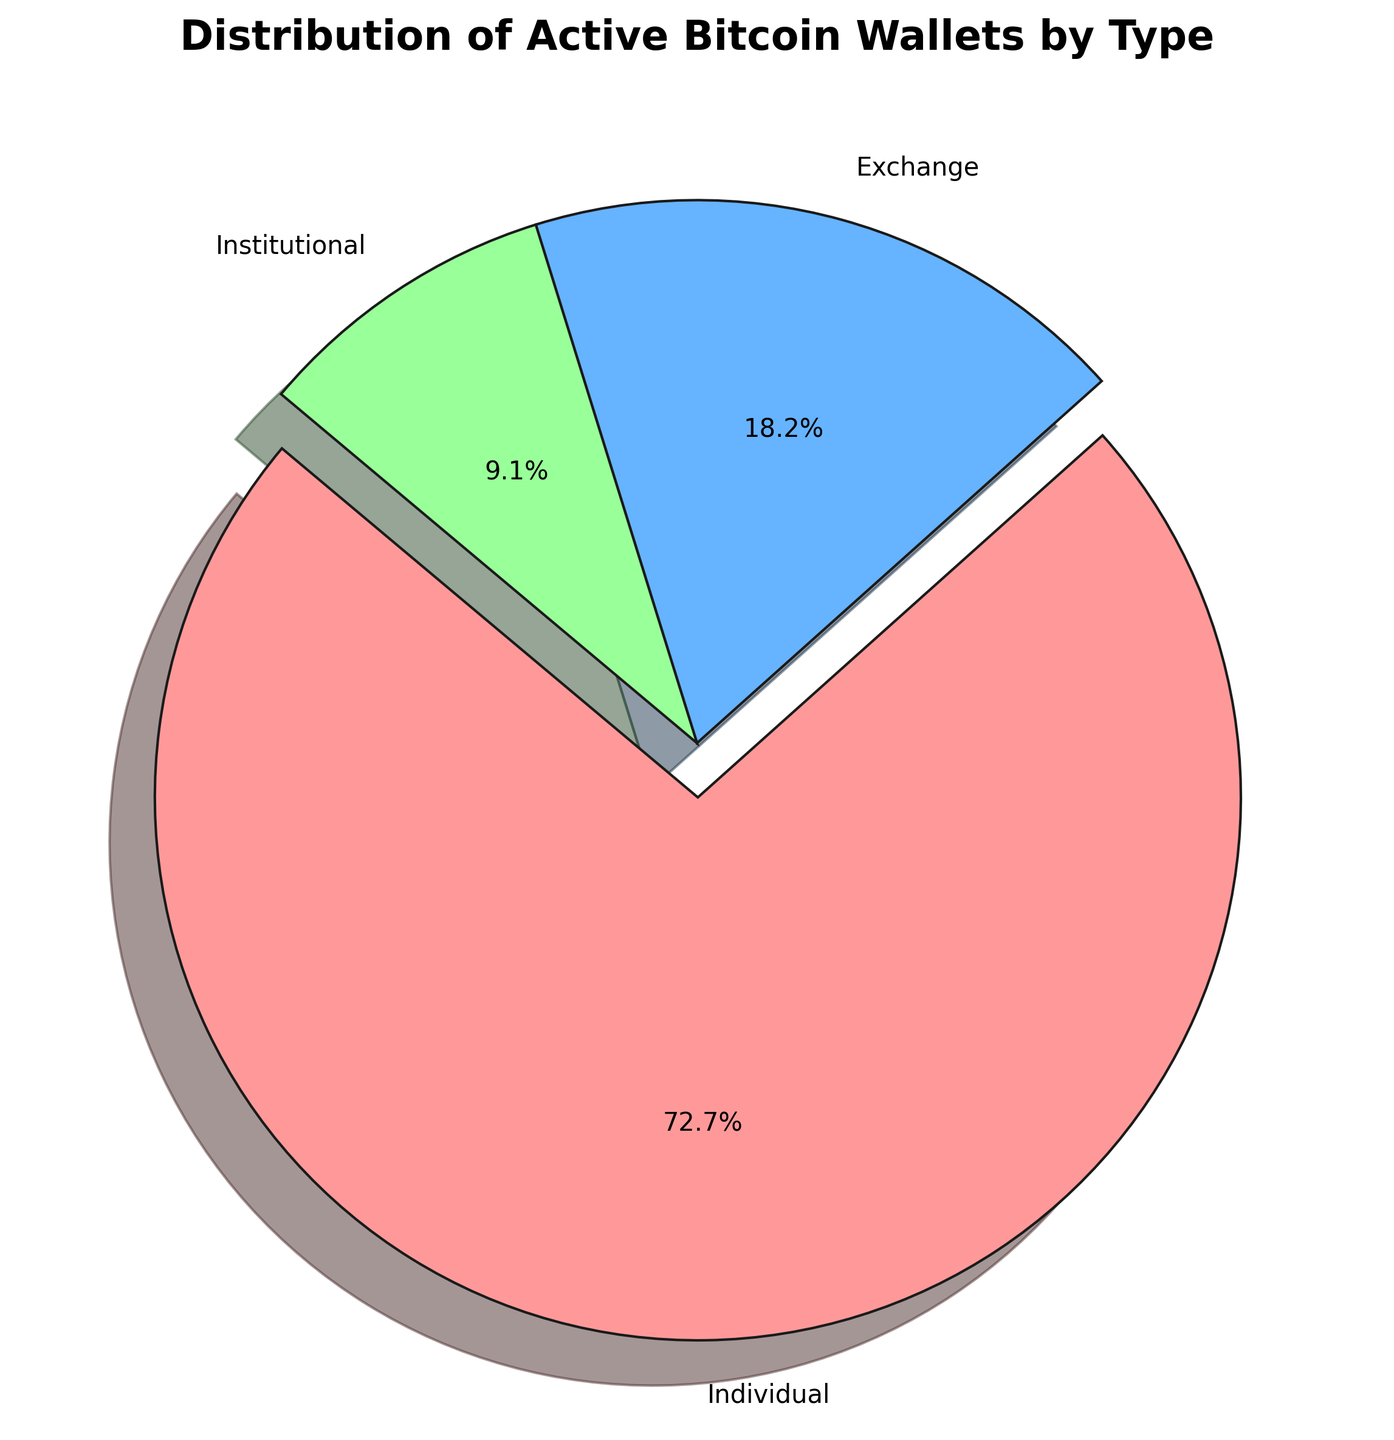Which wallet type has the highest distribution percentage? By looking at the pie chart, the segment representing individual wallets occupies the largest space with an explosion effect, indicating it has the highest percentage.
Answer: Individual What percentage of active Bitcoin wallets are institutional? According to the pie chart, the institutional wallets' segment has a percentage label.
Answer: 7.1% How many more individual wallets are there compared to exchange wallets? The count of individual wallets is 20,000,000 and for exchange wallets, it is 5,000,000. Subtract exchange wallets from individual wallets: 20,000,000 - 5,000,000 = 15,000,000.
Answer: 15,000,000 What is the combined percentage of exchange and institutional wallets? The pie chart shows percentages for exchange and institutional wallets. Adding these two percentages will give the combined percentage. Exchange is 17.9% and Institutional is 7.1%, so 17.9% + 7.1% = 25%.
Answer: 25% Is the percentage of individual wallets more than twice the percentage of exchange wallets? The individual wallets are 71.4%, and exchange wallets are 17.9%. Twice the percentage of exchange wallets is 2 * 17.9% = 35.8%. Since 71.4% is greater than 35.8%, the answer is yes.
Answer: Yes Which segment is represented by the green color in the pie chart? Observing the colors in the pie chart, the green-colored section represents institutional wallets.
Answer: Institutional What is the ratio of individual wallets to institutional wallets? The count of individual wallets is 20,000,000, and institutional wallets are 2,500,000. The ratio is 20,000,000:2,500,000 or simplified as 8:1.
Answer: 8:1 What is the percentage difference between individual and institutional wallets? The chart shows individual wallets at 71.4% and institutional wallets at 7.1%. The difference is 71.4% - 7.1% = 64.3%.
Answer: 64.3% If we combined exchange and institutional wallets, would they have a higher count than individual wallets? Adding the counts of exchange and institutional wallets gives 5,000,000 + 2,500,000 = 7,500,000. Since 7,500,000 is less than 20,000,000, they would not have a higher count than individual wallets.
Answer: No 